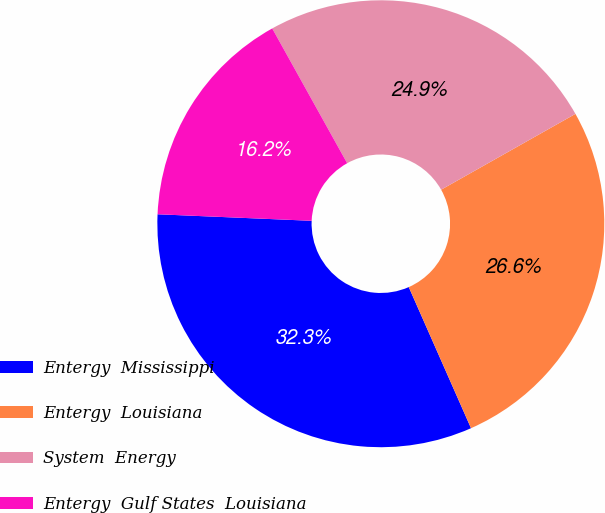<chart> <loc_0><loc_0><loc_500><loc_500><pie_chart><fcel>Entergy  Mississippi<fcel>Entergy  Louisiana<fcel>System  Energy<fcel>Entergy  Gulf States  Louisiana<nl><fcel>32.29%<fcel>26.57%<fcel>24.9%<fcel>16.25%<nl></chart> 